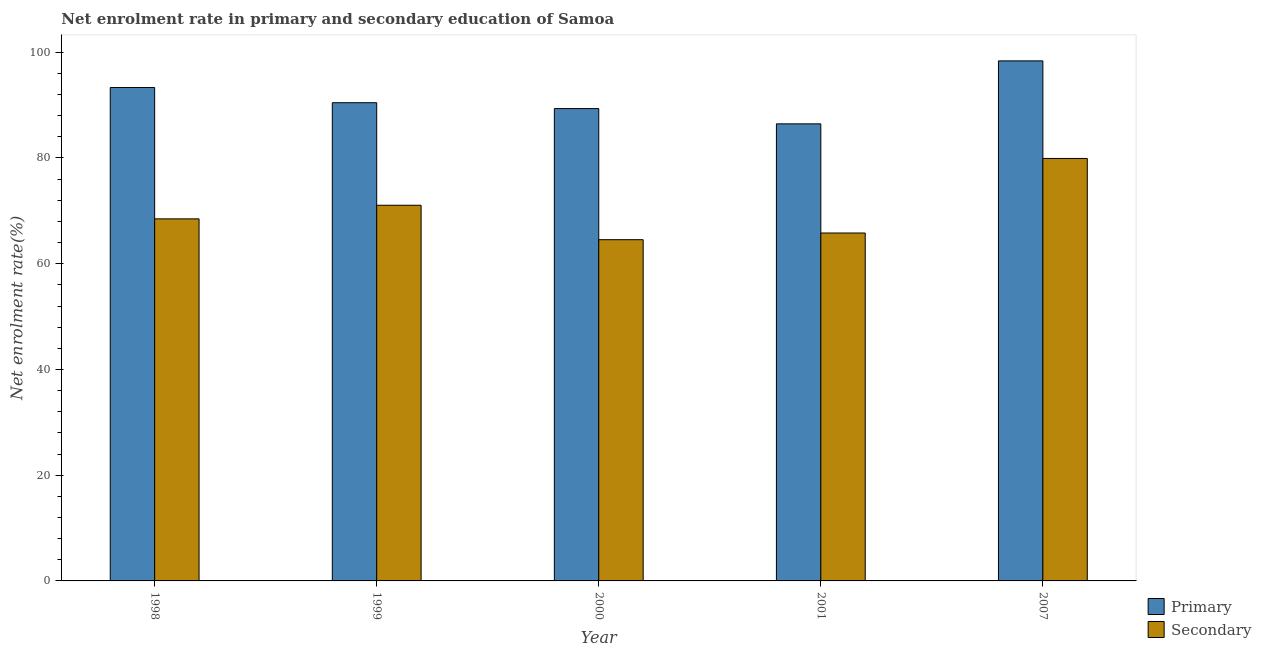How many different coloured bars are there?
Keep it short and to the point. 2. How many groups of bars are there?
Offer a very short reply. 5. Are the number of bars on each tick of the X-axis equal?
Give a very brief answer. Yes. How many bars are there on the 4th tick from the left?
Provide a short and direct response. 2. What is the label of the 3rd group of bars from the left?
Your answer should be very brief. 2000. What is the enrollment rate in primary education in 2007?
Offer a very short reply. 98.37. Across all years, what is the maximum enrollment rate in primary education?
Your answer should be compact. 98.37. Across all years, what is the minimum enrollment rate in secondary education?
Your response must be concise. 64.54. In which year was the enrollment rate in primary education maximum?
Provide a short and direct response. 2007. In which year was the enrollment rate in primary education minimum?
Offer a terse response. 2001. What is the total enrollment rate in secondary education in the graph?
Your response must be concise. 349.81. What is the difference between the enrollment rate in primary education in 2001 and that in 2007?
Keep it short and to the point. -11.91. What is the difference between the enrollment rate in primary education in 1998 and the enrollment rate in secondary education in 1999?
Give a very brief answer. 2.87. What is the average enrollment rate in primary education per year?
Ensure brevity in your answer.  91.59. In how many years, is the enrollment rate in secondary education greater than 8 %?
Provide a succinct answer. 5. What is the ratio of the enrollment rate in secondary education in 1999 to that in 2007?
Offer a terse response. 0.89. Is the enrollment rate in primary education in 2000 less than that in 2001?
Your answer should be very brief. No. Is the difference between the enrollment rate in secondary education in 2000 and 2001 greater than the difference between the enrollment rate in primary education in 2000 and 2001?
Provide a succinct answer. No. What is the difference between the highest and the second highest enrollment rate in primary education?
Give a very brief answer. 5.04. What is the difference between the highest and the lowest enrollment rate in primary education?
Your answer should be very brief. 11.91. Is the sum of the enrollment rate in primary education in 1998 and 2007 greater than the maximum enrollment rate in secondary education across all years?
Provide a succinct answer. Yes. What does the 1st bar from the left in 2001 represents?
Make the answer very short. Primary. What does the 2nd bar from the right in 1998 represents?
Your response must be concise. Primary. What is the difference between two consecutive major ticks on the Y-axis?
Your response must be concise. 20. Are the values on the major ticks of Y-axis written in scientific E-notation?
Give a very brief answer. No. Does the graph contain grids?
Provide a succinct answer. No. Where does the legend appear in the graph?
Offer a very short reply. Bottom right. How many legend labels are there?
Give a very brief answer. 2. How are the legend labels stacked?
Give a very brief answer. Vertical. What is the title of the graph?
Your response must be concise. Net enrolment rate in primary and secondary education of Samoa. What is the label or title of the Y-axis?
Keep it short and to the point. Net enrolment rate(%). What is the Net enrolment rate(%) in Primary in 1998?
Provide a short and direct response. 93.33. What is the Net enrolment rate(%) of Secondary in 1998?
Offer a terse response. 68.49. What is the Net enrolment rate(%) in Primary in 1999?
Your answer should be very brief. 90.46. What is the Net enrolment rate(%) of Secondary in 1999?
Make the answer very short. 71.06. What is the Net enrolment rate(%) of Primary in 2000?
Your answer should be compact. 89.35. What is the Net enrolment rate(%) of Secondary in 2000?
Provide a short and direct response. 64.54. What is the Net enrolment rate(%) of Primary in 2001?
Your answer should be very brief. 86.46. What is the Net enrolment rate(%) in Secondary in 2001?
Offer a very short reply. 65.81. What is the Net enrolment rate(%) of Primary in 2007?
Keep it short and to the point. 98.37. What is the Net enrolment rate(%) in Secondary in 2007?
Provide a succinct answer. 79.91. Across all years, what is the maximum Net enrolment rate(%) in Primary?
Give a very brief answer. 98.37. Across all years, what is the maximum Net enrolment rate(%) of Secondary?
Keep it short and to the point. 79.91. Across all years, what is the minimum Net enrolment rate(%) in Primary?
Give a very brief answer. 86.46. Across all years, what is the minimum Net enrolment rate(%) of Secondary?
Your response must be concise. 64.54. What is the total Net enrolment rate(%) of Primary in the graph?
Provide a short and direct response. 457.96. What is the total Net enrolment rate(%) of Secondary in the graph?
Offer a very short reply. 349.81. What is the difference between the Net enrolment rate(%) of Primary in 1998 and that in 1999?
Offer a terse response. 2.87. What is the difference between the Net enrolment rate(%) in Secondary in 1998 and that in 1999?
Your answer should be very brief. -2.57. What is the difference between the Net enrolment rate(%) of Primary in 1998 and that in 2000?
Ensure brevity in your answer.  3.98. What is the difference between the Net enrolment rate(%) in Secondary in 1998 and that in 2000?
Your answer should be compact. 3.94. What is the difference between the Net enrolment rate(%) of Primary in 1998 and that in 2001?
Make the answer very short. 6.87. What is the difference between the Net enrolment rate(%) of Secondary in 1998 and that in 2001?
Provide a short and direct response. 2.67. What is the difference between the Net enrolment rate(%) in Primary in 1998 and that in 2007?
Provide a short and direct response. -5.04. What is the difference between the Net enrolment rate(%) of Secondary in 1998 and that in 2007?
Keep it short and to the point. -11.43. What is the difference between the Net enrolment rate(%) in Primary in 1999 and that in 2000?
Offer a very short reply. 1.11. What is the difference between the Net enrolment rate(%) of Secondary in 1999 and that in 2000?
Provide a short and direct response. 6.52. What is the difference between the Net enrolment rate(%) of Primary in 1999 and that in 2001?
Keep it short and to the point. 4. What is the difference between the Net enrolment rate(%) of Secondary in 1999 and that in 2001?
Your answer should be very brief. 5.25. What is the difference between the Net enrolment rate(%) in Primary in 1999 and that in 2007?
Offer a very short reply. -7.91. What is the difference between the Net enrolment rate(%) of Secondary in 1999 and that in 2007?
Ensure brevity in your answer.  -8.85. What is the difference between the Net enrolment rate(%) in Primary in 2000 and that in 2001?
Provide a short and direct response. 2.89. What is the difference between the Net enrolment rate(%) of Secondary in 2000 and that in 2001?
Your response must be concise. -1.27. What is the difference between the Net enrolment rate(%) in Primary in 2000 and that in 2007?
Offer a terse response. -9.02. What is the difference between the Net enrolment rate(%) in Secondary in 2000 and that in 2007?
Your answer should be compact. -15.37. What is the difference between the Net enrolment rate(%) of Primary in 2001 and that in 2007?
Offer a very short reply. -11.91. What is the difference between the Net enrolment rate(%) in Secondary in 2001 and that in 2007?
Offer a very short reply. -14.1. What is the difference between the Net enrolment rate(%) in Primary in 1998 and the Net enrolment rate(%) in Secondary in 1999?
Provide a succinct answer. 22.27. What is the difference between the Net enrolment rate(%) of Primary in 1998 and the Net enrolment rate(%) of Secondary in 2000?
Offer a terse response. 28.79. What is the difference between the Net enrolment rate(%) of Primary in 1998 and the Net enrolment rate(%) of Secondary in 2001?
Keep it short and to the point. 27.52. What is the difference between the Net enrolment rate(%) in Primary in 1998 and the Net enrolment rate(%) in Secondary in 2007?
Your answer should be very brief. 13.42. What is the difference between the Net enrolment rate(%) in Primary in 1999 and the Net enrolment rate(%) in Secondary in 2000?
Give a very brief answer. 25.91. What is the difference between the Net enrolment rate(%) in Primary in 1999 and the Net enrolment rate(%) in Secondary in 2001?
Your answer should be compact. 24.65. What is the difference between the Net enrolment rate(%) in Primary in 1999 and the Net enrolment rate(%) in Secondary in 2007?
Offer a terse response. 10.55. What is the difference between the Net enrolment rate(%) of Primary in 2000 and the Net enrolment rate(%) of Secondary in 2001?
Your answer should be very brief. 23.54. What is the difference between the Net enrolment rate(%) in Primary in 2000 and the Net enrolment rate(%) in Secondary in 2007?
Offer a terse response. 9.44. What is the difference between the Net enrolment rate(%) in Primary in 2001 and the Net enrolment rate(%) in Secondary in 2007?
Make the answer very short. 6.55. What is the average Net enrolment rate(%) in Primary per year?
Offer a terse response. 91.59. What is the average Net enrolment rate(%) of Secondary per year?
Keep it short and to the point. 69.96. In the year 1998, what is the difference between the Net enrolment rate(%) of Primary and Net enrolment rate(%) of Secondary?
Provide a succinct answer. 24.84. In the year 1999, what is the difference between the Net enrolment rate(%) of Primary and Net enrolment rate(%) of Secondary?
Ensure brevity in your answer.  19.4. In the year 2000, what is the difference between the Net enrolment rate(%) in Primary and Net enrolment rate(%) in Secondary?
Your answer should be very brief. 24.8. In the year 2001, what is the difference between the Net enrolment rate(%) of Primary and Net enrolment rate(%) of Secondary?
Give a very brief answer. 20.65. In the year 2007, what is the difference between the Net enrolment rate(%) of Primary and Net enrolment rate(%) of Secondary?
Your answer should be compact. 18.46. What is the ratio of the Net enrolment rate(%) of Primary in 1998 to that in 1999?
Offer a very short reply. 1.03. What is the ratio of the Net enrolment rate(%) in Secondary in 1998 to that in 1999?
Provide a succinct answer. 0.96. What is the ratio of the Net enrolment rate(%) of Primary in 1998 to that in 2000?
Provide a succinct answer. 1.04. What is the ratio of the Net enrolment rate(%) in Secondary in 1998 to that in 2000?
Make the answer very short. 1.06. What is the ratio of the Net enrolment rate(%) of Primary in 1998 to that in 2001?
Your response must be concise. 1.08. What is the ratio of the Net enrolment rate(%) in Secondary in 1998 to that in 2001?
Your response must be concise. 1.04. What is the ratio of the Net enrolment rate(%) in Primary in 1998 to that in 2007?
Provide a succinct answer. 0.95. What is the ratio of the Net enrolment rate(%) in Secondary in 1998 to that in 2007?
Make the answer very short. 0.86. What is the ratio of the Net enrolment rate(%) of Primary in 1999 to that in 2000?
Provide a succinct answer. 1.01. What is the ratio of the Net enrolment rate(%) of Secondary in 1999 to that in 2000?
Your answer should be very brief. 1.1. What is the ratio of the Net enrolment rate(%) in Primary in 1999 to that in 2001?
Ensure brevity in your answer.  1.05. What is the ratio of the Net enrolment rate(%) of Secondary in 1999 to that in 2001?
Make the answer very short. 1.08. What is the ratio of the Net enrolment rate(%) in Primary in 1999 to that in 2007?
Offer a very short reply. 0.92. What is the ratio of the Net enrolment rate(%) in Secondary in 1999 to that in 2007?
Your answer should be very brief. 0.89. What is the ratio of the Net enrolment rate(%) in Primary in 2000 to that in 2001?
Offer a terse response. 1.03. What is the ratio of the Net enrolment rate(%) in Secondary in 2000 to that in 2001?
Make the answer very short. 0.98. What is the ratio of the Net enrolment rate(%) in Primary in 2000 to that in 2007?
Keep it short and to the point. 0.91. What is the ratio of the Net enrolment rate(%) of Secondary in 2000 to that in 2007?
Offer a very short reply. 0.81. What is the ratio of the Net enrolment rate(%) in Primary in 2001 to that in 2007?
Your answer should be very brief. 0.88. What is the ratio of the Net enrolment rate(%) in Secondary in 2001 to that in 2007?
Provide a succinct answer. 0.82. What is the difference between the highest and the second highest Net enrolment rate(%) of Primary?
Ensure brevity in your answer.  5.04. What is the difference between the highest and the second highest Net enrolment rate(%) of Secondary?
Provide a short and direct response. 8.85. What is the difference between the highest and the lowest Net enrolment rate(%) of Primary?
Provide a short and direct response. 11.91. What is the difference between the highest and the lowest Net enrolment rate(%) of Secondary?
Offer a terse response. 15.37. 